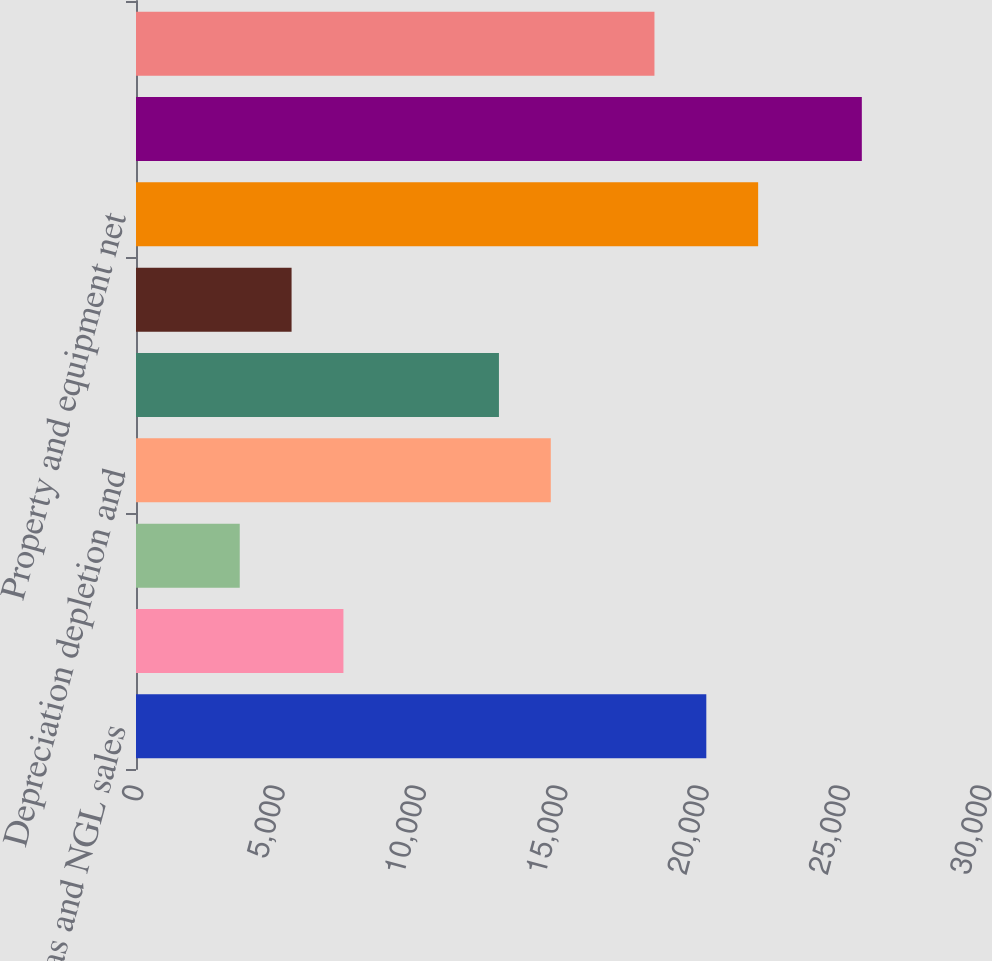<chart> <loc_0><loc_0><loc_500><loc_500><bar_chart><fcel>Oil gas and NGL sales<fcel>Marketing and midstream<fcel>Interest expense<fcel>Depreciation depletion and<fcel>Earnings from continuing<fcel>Income tax expense<fcel>Property and equipment net<fcel>Total continuing assets(1)<fcel>Capital expenditures<nl><fcel>20176<fcel>7338<fcel>3670<fcel>14674<fcel>12840<fcel>5504<fcel>22010<fcel>25678<fcel>18342<nl></chart> 